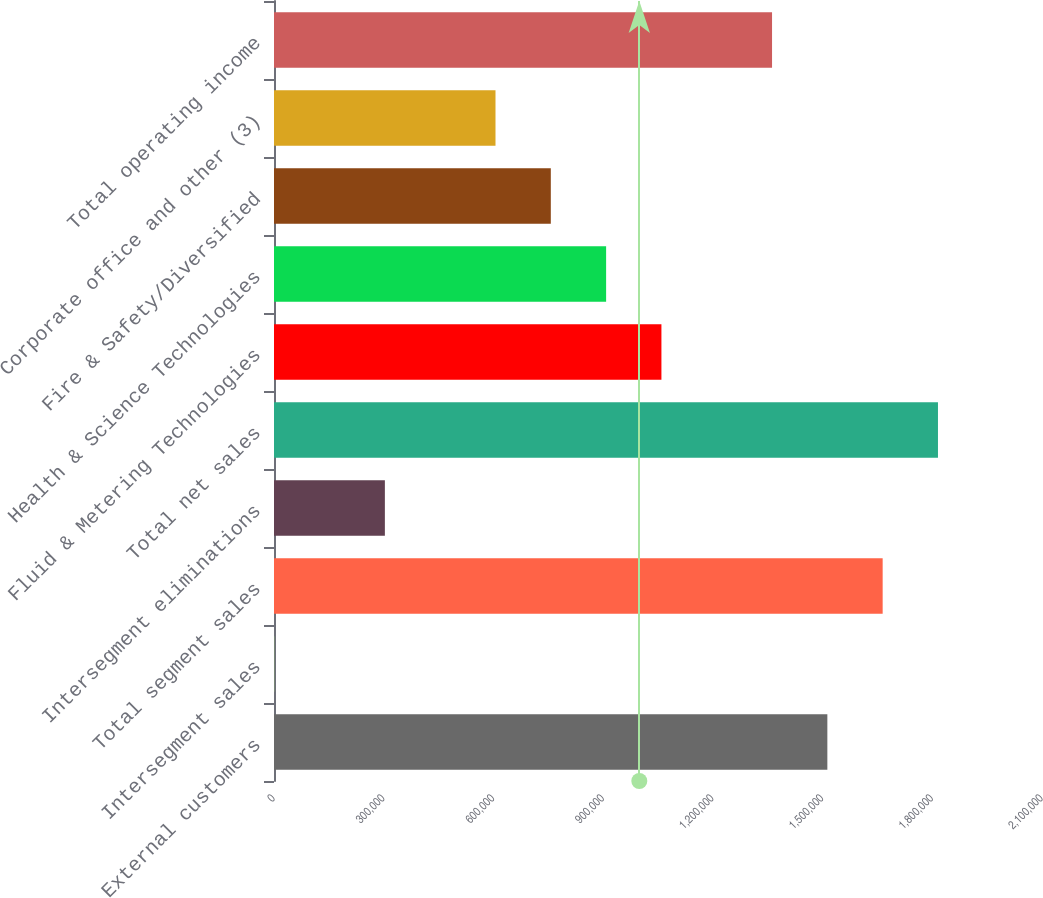<chart> <loc_0><loc_0><loc_500><loc_500><bar_chart><fcel>External customers<fcel>Intersegment sales<fcel>Total segment sales<fcel>Intersegment eliminations<fcel>Total net sales<fcel>Fluid & Metering Technologies<fcel>Health & Science Technologies<fcel>Fire & Safety/Diversified<fcel>Corporate office and other (3)<fcel>Total operating income<nl><fcel>1.51307e+06<fcel>712<fcel>1.66431e+06<fcel>303184<fcel>1.81555e+06<fcel>1.05936e+06<fcel>908129<fcel>756892<fcel>605656<fcel>1.36184e+06<nl></chart> 